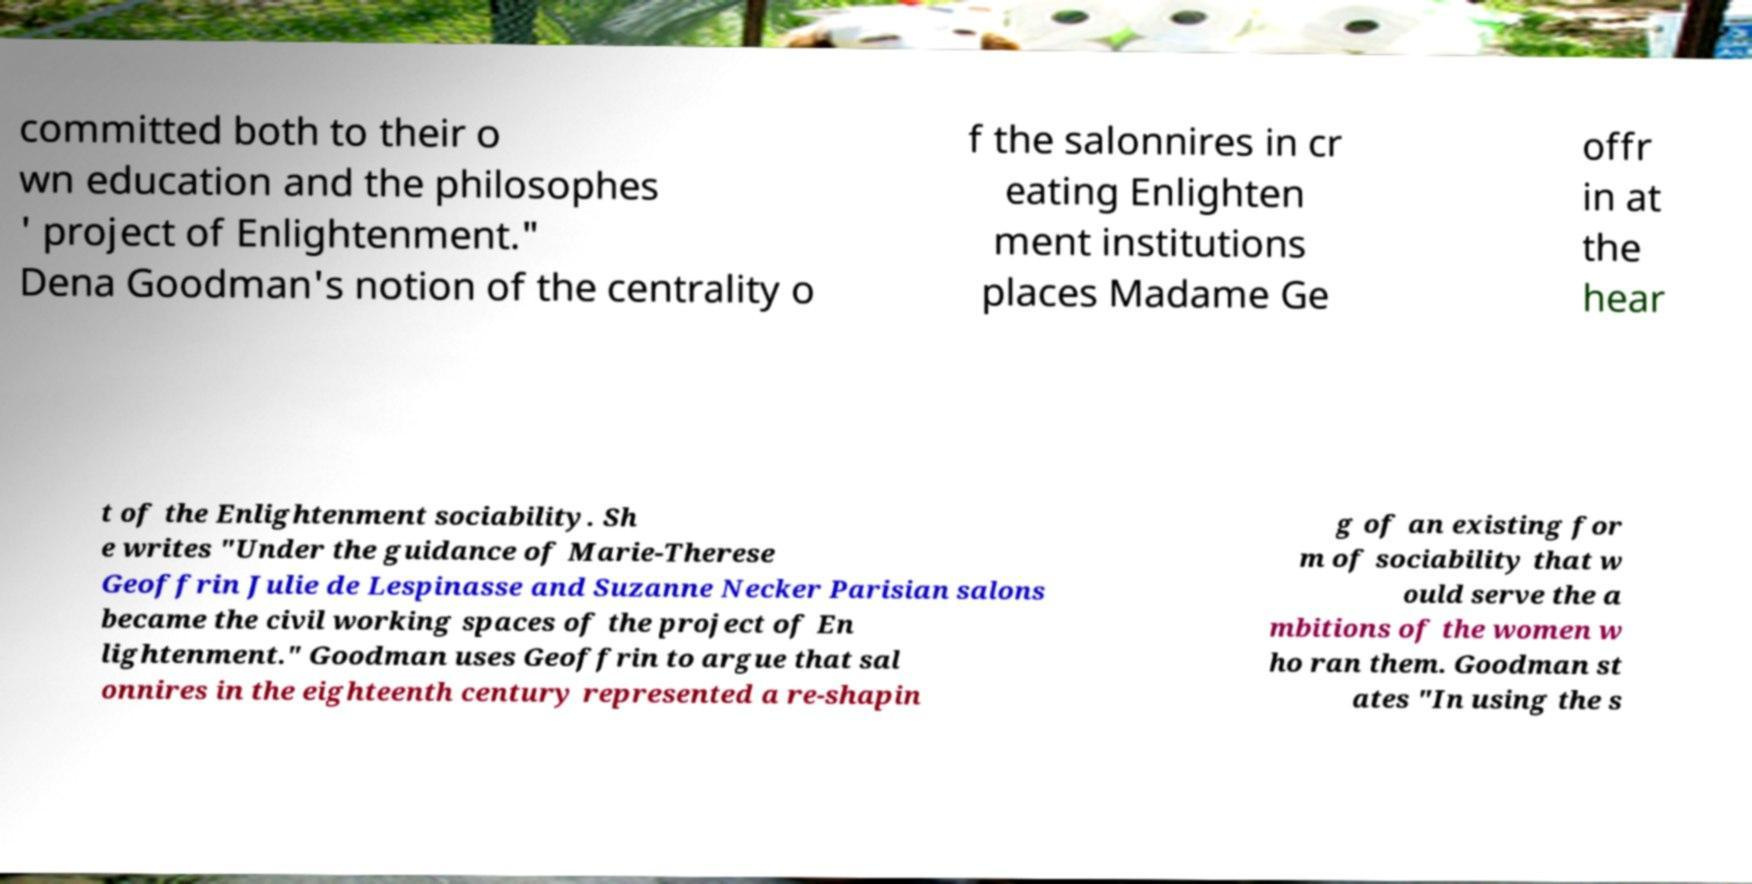There's text embedded in this image that I need extracted. Can you transcribe it verbatim? committed both to their o wn education and the philosophes ' project of Enlightenment." Dena Goodman's notion of the centrality o f the salonnires in cr eating Enlighten ment institutions places Madame Ge offr in at the hear t of the Enlightenment sociability. Sh e writes "Under the guidance of Marie-Therese Geoffrin Julie de Lespinasse and Suzanne Necker Parisian salons became the civil working spaces of the project of En lightenment." Goodman uses Geoffrin to argue that sal onnires in the eighteenth century represented a re-shapin g of an existing for m of sociability that w ould serve the a mbitions of the women w ho ran them. Goodman st ates "In using the s 